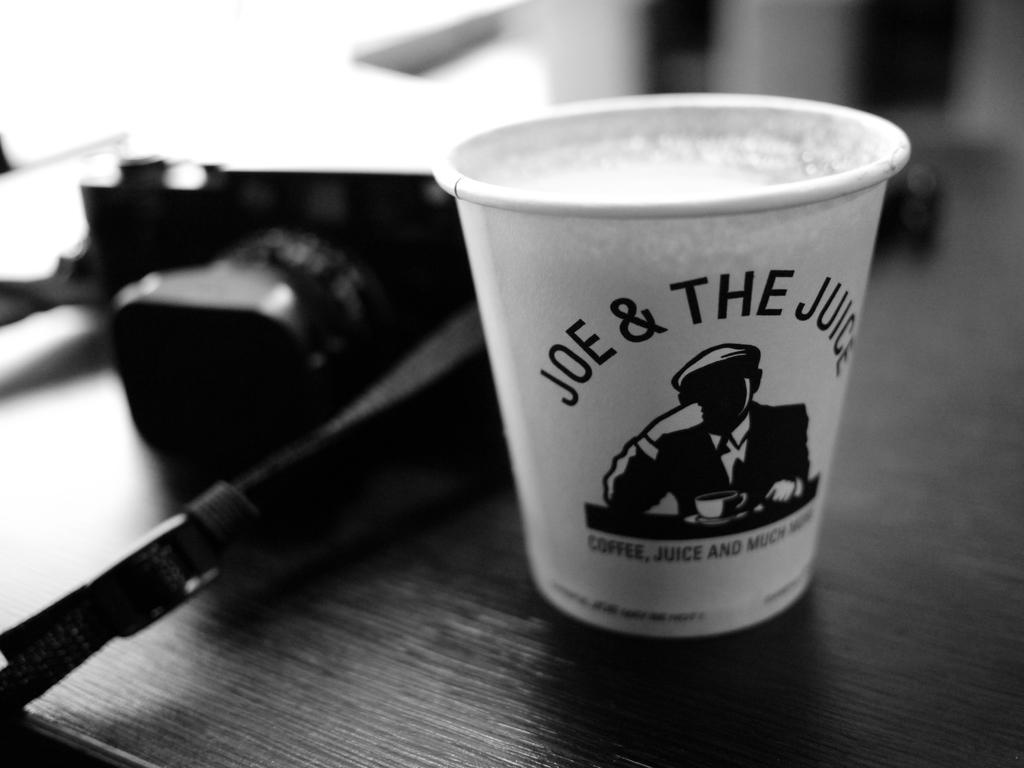Provide a one-sentence caption for the provided image. A cup from Joe and the Juice sits on a wooden table. 